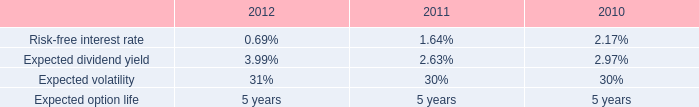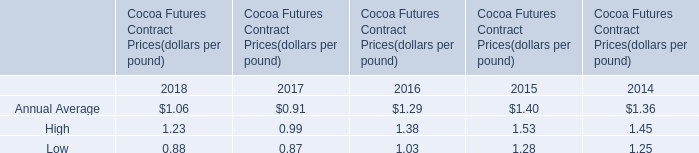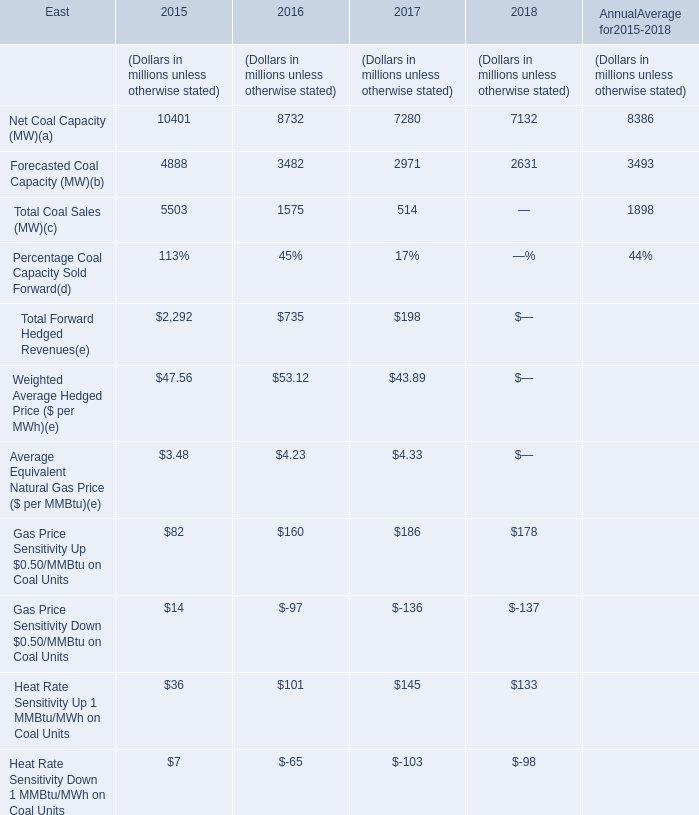In the year with largest amount of Net Coal Capacity (MW) in Table 2, what's the increasing rate of High in Table 1? 
Computations: ((1.53 - 1.45) / 1.45)
Answer: 0.05517. 